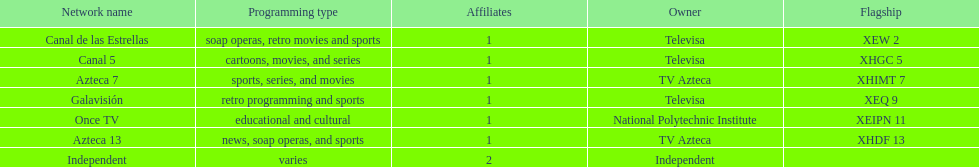How many networks does tv azteca own? 2. 